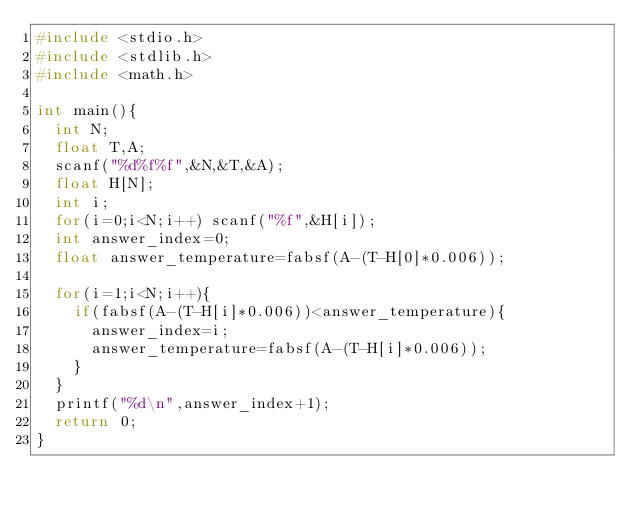Convert code to text. <code><loc_0><loc_0><loc_500><loc_500><_C_>#include <stdio.h>
#include <stdlib.h>
#include <math.h>

int main(){
  int N;
  float T,A;
  scanf("%d%f%f",&N,&T,&A);
  float H[N];
  int i;
  for(i=0;i<N;i++) scanf("%f",&H[i]);
  int answer_index=0;
  float answer_temperature=fabsf(A-(T-H[0]*0.006));

  for(i=1;i<N;i++){
    if(fabsf(A-(T-H[i]*0.006))<answer_temperature){
      answer_index=i;
      answer_temperature=fabsf(A-(T-H[i]*0.006));
    }
  }
  printf("%d\n",answer_index+1);
  return 0;
}
</code> 